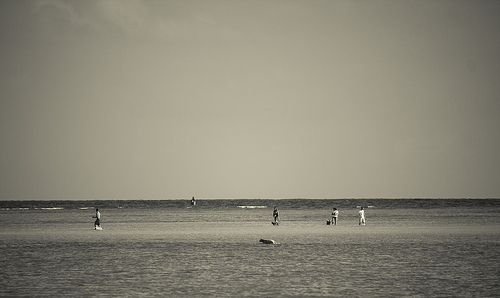Please provide the bounding box coordinate of the region this sentence describes: The board is white. [0.15, 0.59, 0.22, 0.66] Please provide a short description for this region: [0.53, 0.6, 0.57, 0.66]. A person in walking. Please provide the bounding box coordinate of the region this sentence describes: a person in standing. [0.53, 0.6, 0.57, 0.66] Please provide a short description for this region: [0.18, 0.61, 0.56, 0.65]. Two people wearing black. Please provide the bounding box coordinate of the region this sentence describes: a person in walking. [0.64, 0.61, 0.69, 0.66] Please provide a short description for this region: [0.71, 0.61, 0.73, 0.67]. The man is wearing a white t-shirt. Please provide the bounding box coordinate of the region this sentence describes: Person walking a dog on the beach. [0.53, 0.61, 0.58, 0.67] Please provide the bounding box coordinate of the region this sentence describes: a person in standing. [0.7, 0.61, 0.75, 0.67] Please provide the bounding box coordinate of the region this sentence describes: Man with no shirt standing on the beach. [0.16, 0.61, 0.22, 0.67] Please provide a short description for this region: [0.13, 0.7, 0.93, 0.79]. Sand at the beach. 